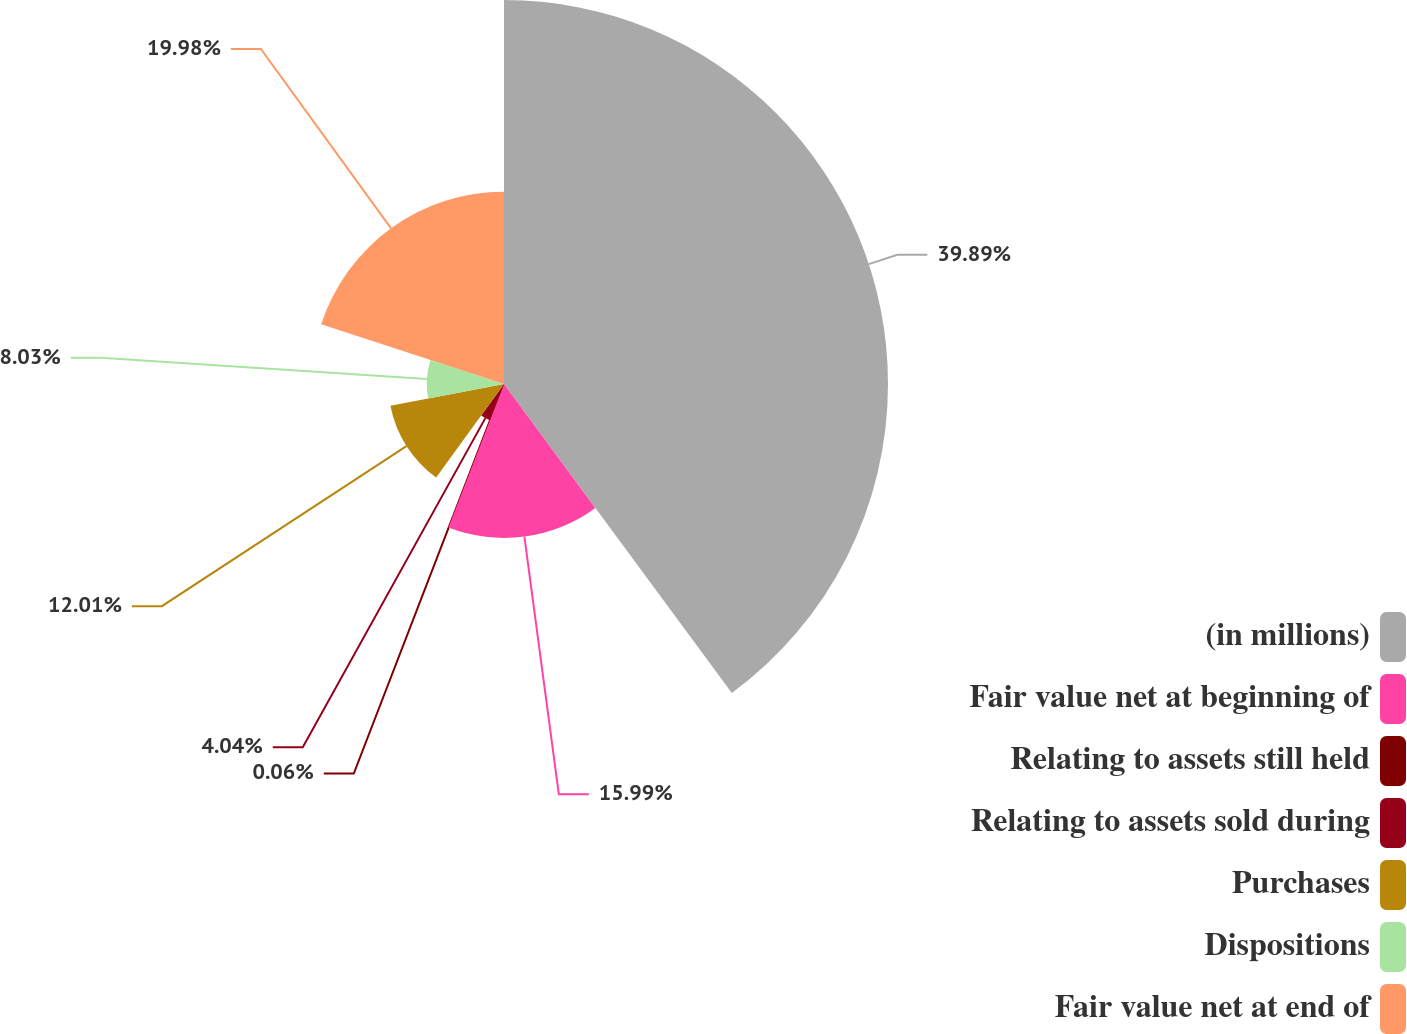Convert chart to OTSL. <chart><loc_0><loc_0><loc_500><loc_500><pie_chart><fcel>(in millions)<fcel>Fair value net at beginning of<fcel>Relating to assets still held<fcel>Relating to assets sold during<fcel>Purchases<fcel>Dispositions<fcel>Fair value net at end of<nl><fcel>39.89%<fcel>15.99%<fcel>0.06%<fcel>4.04%<fcel>12.01%<fcel>8.03%<fcel>19.98%<nl></chart> 